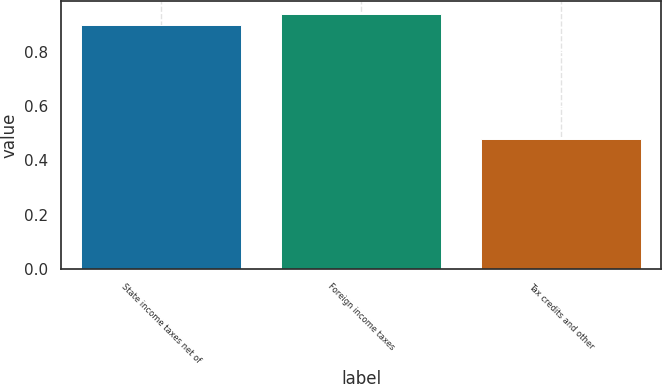Convert chart to OTSL. <chart><loc_0><loc_0><loc_500><loc_500><bar_chart><fcel>State income taxes net of<fcel>Foreign income taxes<fcel>Tax credits and other<nl><fcel>0.9<fcel>0.94<fcel>0.48<nl></chart> 